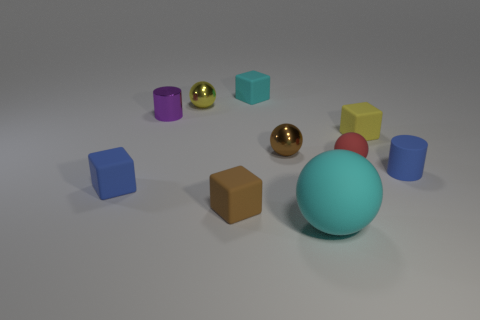How many other things are there of the same size as the shiny cylinder?
Your response must be concise. 8. What material is the small cylinder to the left of the small rubber thing that is behind the yellow thing left of the small brown rubber block?
Ensure brevity in your answer.  Metal. There is a blue matte cylinder; is its size the same as the cyan object that is behind the purple object?
Your response must be concise. Yes. There is a ball that is in front of the brown metallic sphere and behind the large cyan ball; how big is it?
Give a very brief answer. Small. Are there any balls of the same color as the big matte thing?
Ensure brevity in your answer.  No. What is the color of the tiny cylinder on the left side of the tiny brown object that is on the right side of the tiny cyan rubber cube?
Provide a short and direct response. Purple. Is the number of red matte spheres in front of the brown block less than the number of cylinders left of the brown metal thing?
Your answer should be very brief. Yes. Do the blue block and the red sphere have the same size?
Your answer should be compact. Yes. There is a thing that is to the left of the small matte cylinder and on the right side of the red matte thing; what is its shape?
Make the answer very short. Cube. How many blue objects are the same material as the tiny cyan cube?
Provide a succinct answer. 2. 